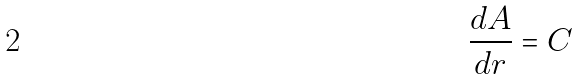<formula> <loc_0><loc_0><loc_500><loc_500>\frac { d A } { d r } = C</formula> 